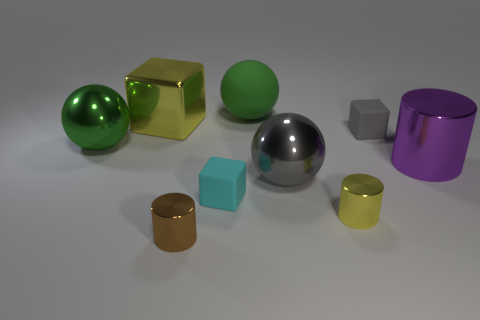What number of cylinders are either small cyan matte things or yellow things?
Offer a very short reply. 1. There is a big cylinder that is made of the same material as the small brown object; what is its color?
Your answer should be very brief. Purple. Is the material of the large purple cylinder the same as the object behind the big yellow cube?
Make the answer very short. No. How many things are either small things or large gray metallic objects?
Provide a succinct answer. 5. What material is the cylinder that is the same color as the big metallic cube?
Make the answer very short. Metal. Is there a small cyan rubber object that has the same shape as the brown metallic object?
Provide a succinct answer. No. There is a cyan rubber block; how many yellow metallic objects are in front of it?
Offer a very short reply. 1. What is the material of the yellow object that is behind the big green sphere in front of the yellow cube?
Your response must be concise. Metal. There is a gray block that is the same size as the yellow cylinder; what is its material?
Provide a succinct answer. Rubber. Is there a gray block that has the same size as the cyan block?
Provide a succinct answer. Yes. 